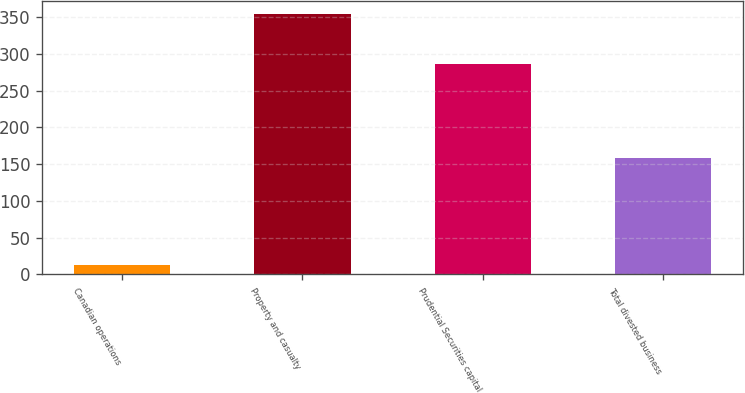Convert chart to OTSL. <chart><loc_0><loc_0><loc_500><loc_500><bar_chart><fcel>Canadian operations<fcel>Property and casualty<fcel>Prudential Securities capital<fcel>Total divested business<nl><fcel>13<fcel>355<fcel>287<fcel>158<nl></chart> 